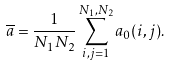<formula> <loc_0><loc_0><loc_500><loc_500>\overline { a } = \frac { 1 } { N _ { 1 } N _ { 2 } } \sum _ { i , j = 1 } ^ { N _ { 1 } , N _ { 2 } } a _ { 0 } ( i , j ) .</formula> 